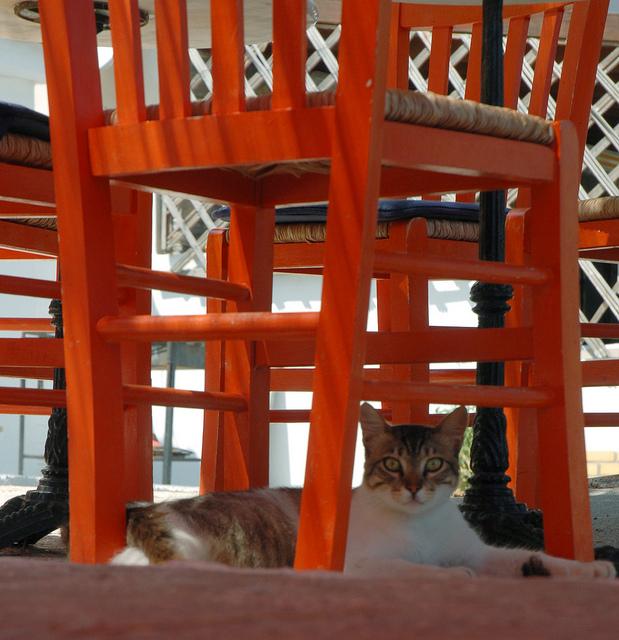What is the chair made out of?
Be succinct. Wood. Is this cat hiding?
Write a very short answer. Yes. What color is the cat?
Be succinct. White and brown. 